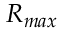Convert formula to latex. <formula><loc_0><loc_0><loc_500><loc_500>R _ { \max }</formula> 